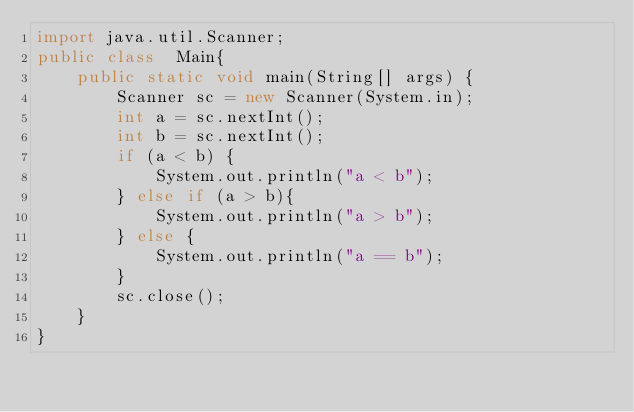<code> <loc_0><loc_0><loc_500><loc_500><_Java_>import java.util.Scanner;
public class  Main{ 
    public static void main(String[] args) { 
        Scanner sc = new Scanner(System.in);
        int a = sc.nextInt();
        int b = sc.nextInt();
        if (a < b) { 
            System.out.println("a < b");
        } else if (a > b){
            System.out.println("a > b");
        } else {
            System.out.println("a == b");
        }
        sc.close();
    }
}   
</code> 